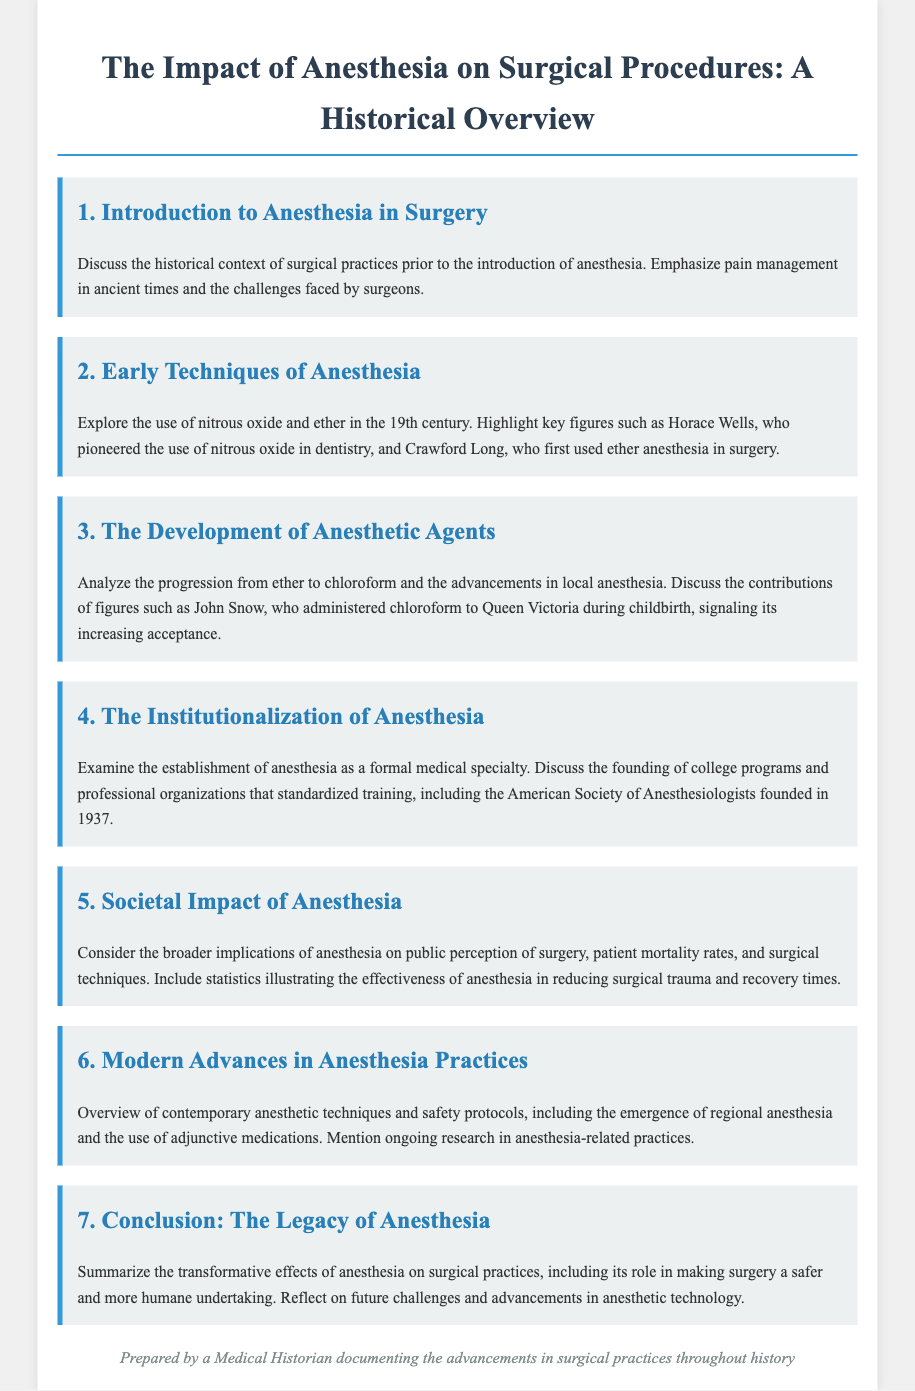What is the first agenda item? The first agenda item is an introduction to anesthesia in surgery, which discusses the historical context of surgical practices prior to the introduction of anesthesia.
Answer: Introduction to Anesthesia in Surgery Who pioneered the use of nitrous oxide? Horace Wells is noted for pioneering the use of nitrous oxide in dentistry during the early techniques of anesthesia.
Answer: Horace Wells What year was the American Society of Anesthesiologists founded? The founding year of the American Society of Anesthesiologists is 1937, which marked the institutionalization of anesthesia as a formal medical specialty.
Answer: 1937 What was administered to Queen Victoria during childbirth? Chloroform was administered to Queen Victoria during childbirth by John Snow, illustrating the acceptance of this anesthetic agent.
Answer: Chloroform How does anesthesia impact patient mortality rates? The document mentions that anesthesia has broader implications on patient mortality rates, emphasizing its effectiveness in reducing surgical trauma and recovery times.
Answer: Reducing surgical trauma What is a modern advance in anesthesia practices? One modern advance mentioned in the document includes the emergence of regional anesthesia techniques.
Answer: Regional anesthesia What does the conclusion address? The conclusion summarizes the transformative effects of anesthesia on surgical practices and reflects on future challenges and advancements in anesthetic technology.
Answer: The Legacy of Anesthesia 